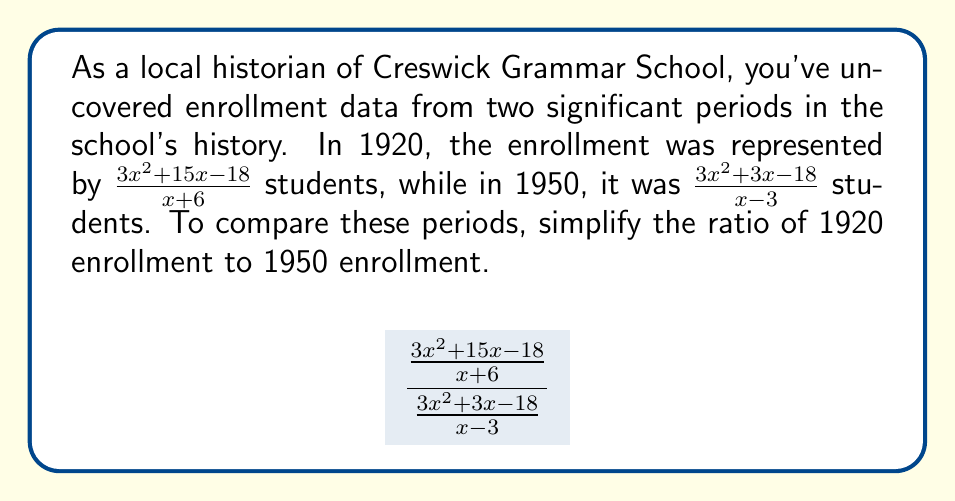Solve this math problem. Let's simplify this rational expression step by step:

1) First, recall that dividing fractions is equivalent to multiplying by the reciprocal. So, we can rewrite our expression as:

   $$\frac{3x^2 + 15x - 18}{x + 6} \cdot \frac{x - 3}{3x^2 + 3x - 18}$$

2) Now, let's factor the numerators and denominators:
   
   $$\frac{3(x^2 + 5x - 6)}{x + 6} \cdot \frac{x - 3}{3(x^2 + x - 6)}$$

   $$\frac{3(x + 6)(x - 1)}{x + 6} \cdot \frac{x - 3}{3(x + 3)(x - 2)}$$

3) The $(x + 6)$ cancels out in the first fraction:

   $$3(x - 1) \cdot \frac{x - 3}{3(x + 3)(x - 2)}$$

4) The 3's cancel out:

   $$(x - 1) \cdot \frac{x - 3}{(x + 3)(x - 2)}$$

5) There are no more common factors to cancel. This is our simplified rational expression.
Answer: $\frac{(x - 1)(x - 3)}{(x + 3)(x - 2)}$ 